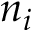Convert formula to latex. <formula><loc_0><loc_0><loc_500><loc_500>n _ { i }</formula> 